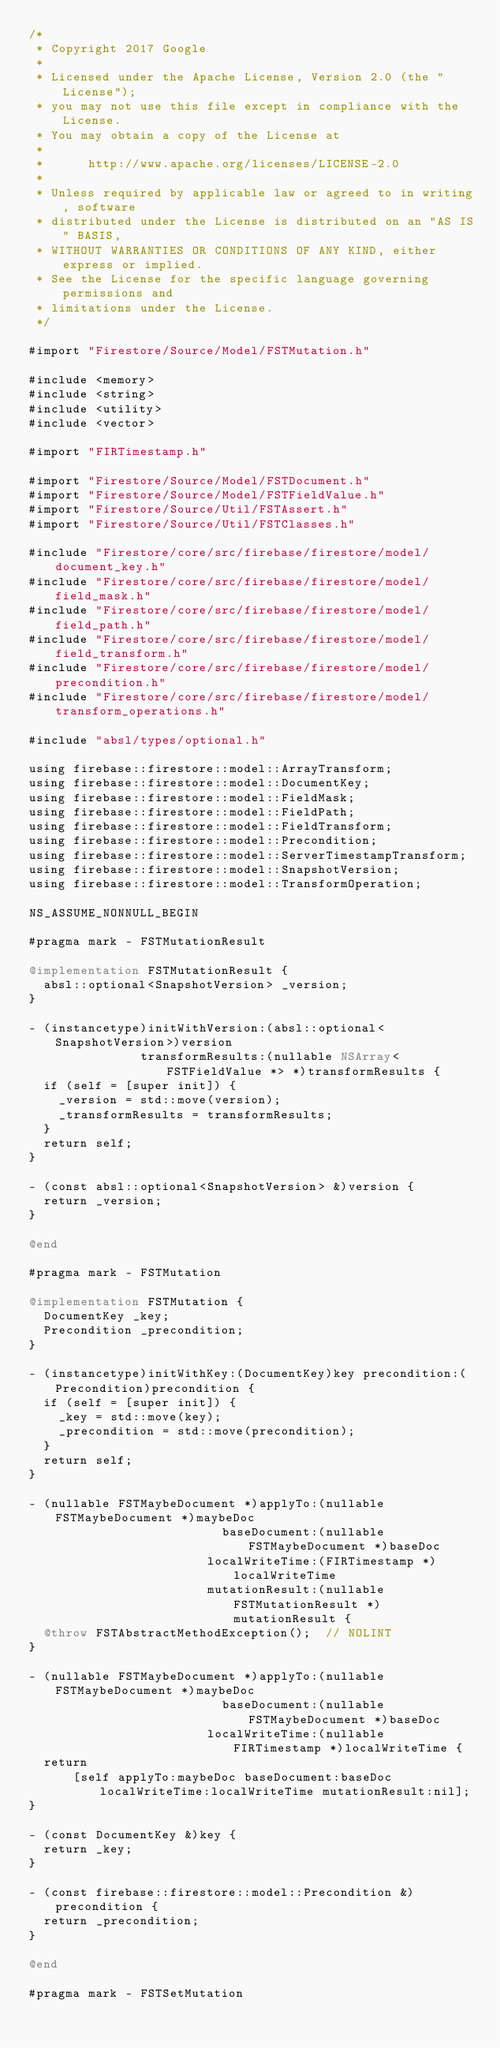<code> <loc_0><loc_0><loc_500><loc_500><_ObjectiveC_>/*
 * Copyright 2017 Google
 *
 * Licensed under the Apache License, Version 2.0 (the "License");
 * you may not use this file except in compliance with the License.
 * You may obtain a copy of the License at
 *
 *      http://www.apache.org/licenses/LICENSE-2.0
 *
 * Unless required by applicable law or agreed to in writing, software
 * distributed under the License is distributed on an "AS IS" BASIS,
 * WITHOUT WARRANTIES OR CONDITIONS OF ANY KIND, either express or implied.
 * See the License for the specific language governing permissions and
 * limitations under the License.
 */

#import "Firestore/Source/Model/FSTMutation.h"

#include <memory>
#include <string>
#include <utility>
#include <vector>

#import "FIRTimestamp.h"

#import "Firestore/Source/Model/FSTDocument.h"
#import "Firestore/Source/Model/FSTFieldValue.h"
#import "Firestore/Source/Util/FSTAssert.h"
#import "Firestore/Source/Util/FSTClasses.h"

#include "Firestore/core/src/firebase/firestore/model/document_key.h"
#include "Firestore/core/src/firebase/firestore/model/field_mask.h"
#include "Firestore/core/src/firebase/firestore/model/field_path.h"
#include "Firestore/core/src/firebase/firestore/model/field_transform.h"
#include "Firestore/core/src/firebase/firestore/model/precondition.h"
#include "Firestore/core/src/firebase/firestore/model/transform_operations.h"

#include "absl/types/optional.h"

using firebase::firestore::model::ArrayTransform;
using firebase::firestore::model::DocumentKey;
using firebase::firestore::model::FieldMask;
using firebase::firestore::model::FieldPath;
using firebase::firestore::model::FieldTransform;
using firebase::firestore::model::Precondition;
using firebase::firestore::model::ServerTimestampTransform;
using firebase::firestore::model::SnapshotVersion;
using firebase::firestore::model::TransformOperation;

NS_ASSUME_NONNULL_BEGIN

#pragma mark - FSTMutationResult

@implementation FSTMutationResult {
  absl::optional<SnapshotVersion> _version;
}

- (instancetype)initWithVersion:(absl::optional<SnapshotVersion>)version
               transformResults:(nullable NSArray<FSTFieldValue *> *)transformResults {
  if (self = [super init]) {
    _version = std::move(version);
    _transformResults = transformResults;
  }
  return self;
}

- (const absl::optional<SnapshotVersion> &)version {
  return _version;
}

@end

#pragma mark - FSTMutation

@implementation FSTMutation {
  DocumentKey _key;
  Precondition _precondition;
}

- (instancetype)initWithKey:(DocumentKey)key precondition:(Precondition)precondition {
  if (self = [super init]) {
    _key = std::move(key);
    _precondition = std::move(precondition);
  }
  return self;
}

- (nullable FSTMaybeDocument *)applyTo:(nullable FSTMaybeDocument *)maybeDoc
                          baseDocument:(nullable FSTMaybeDocument *)baseDoc
                        localWriteTime:(FIRTimestamp *)localWriteTime
                        mutationResult:(nullable FSTMutationResult *)mutationResult {
  @throw FSTAbstractMethodException();  // NOLINT
}

- (nullable FSTMaybeDocument *)applyTo:(nullable FSTMaybeDocument *)maybeDoc
                          baseDocument:(nullable FSTMaybeDocument *)baseDoc
                        localWriteTime:(nullable FIRTimestamp *)localWriteTime {
  return
      [self applyTo:maybeDoc baseDocument:baseDoc localWriteTime:localWriteTime mutationResult:nil];
}

- (const DocumentKey &)key {
  return _key;
}

- (const firebase::firestore::model::Precondition &)precondition {
  return _precondition;
}

@end

#pragma mark - FSTSetMutation
</code> 